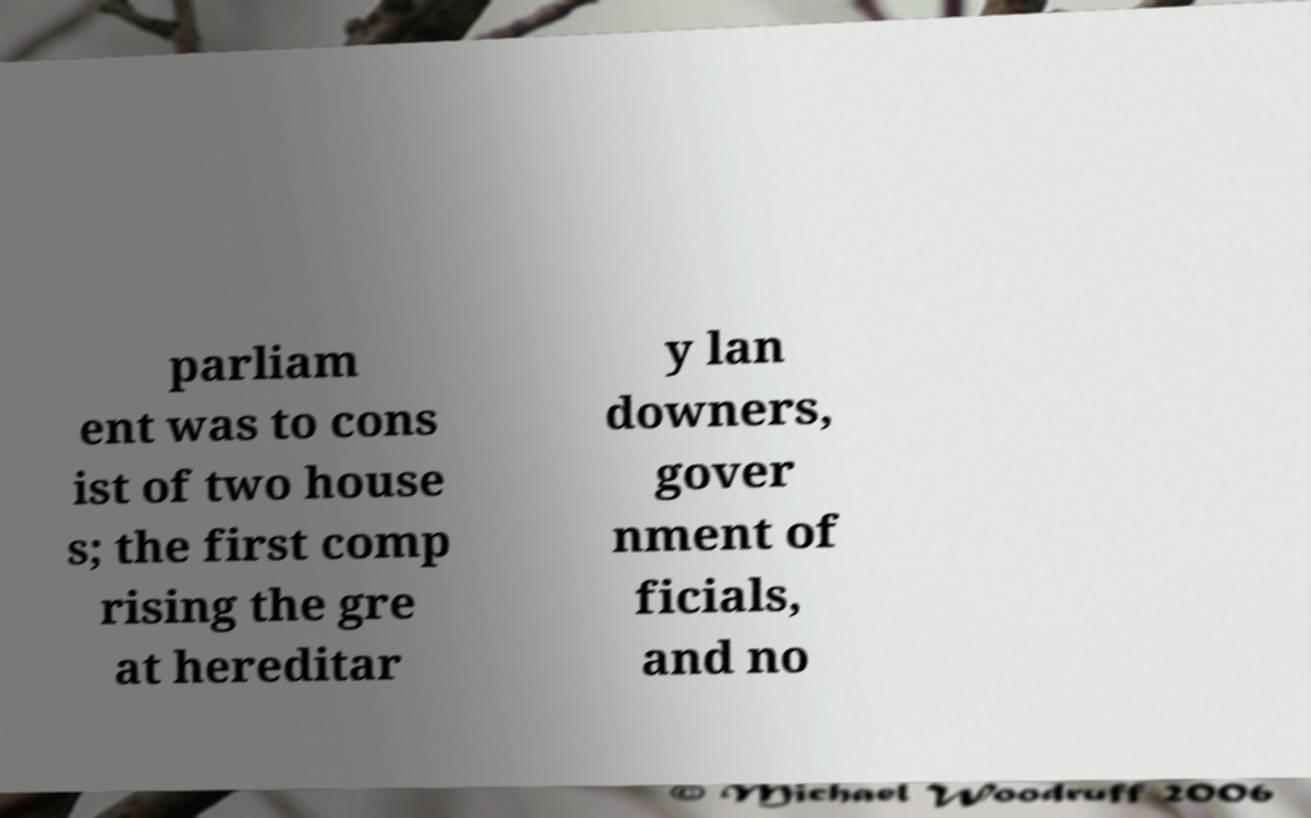What messages or text are displayed in this image? I need them in a readable, typed format. parliam ent was to cons ist of two house s; the first comp rising the gre at hereditar y lan downers, gover nment of ficials, and no 